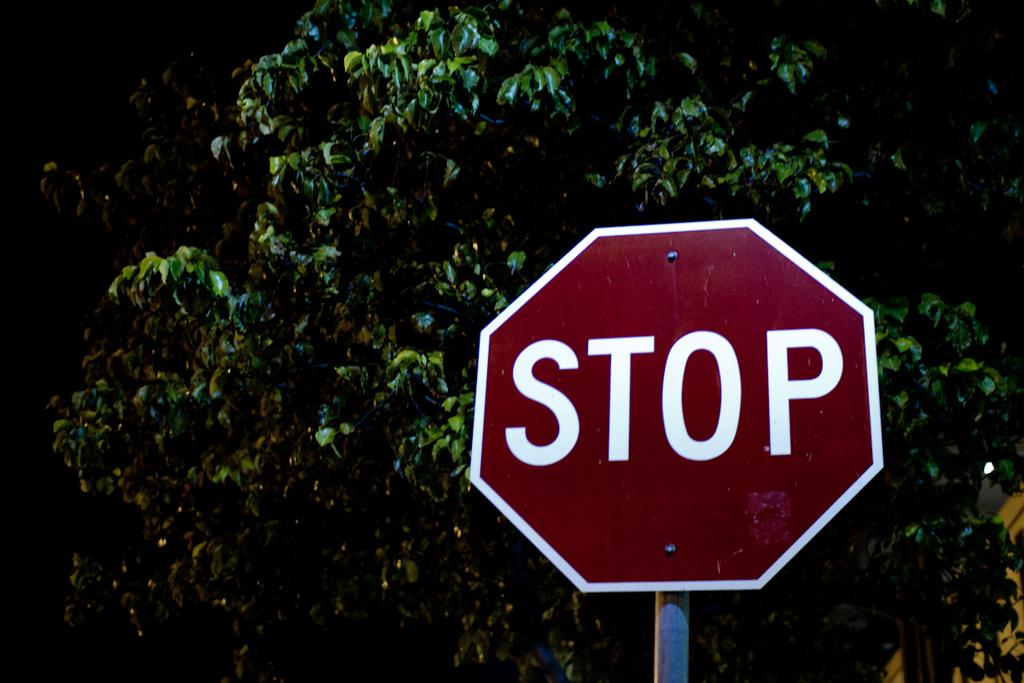Provide a one-sentence caption for the provided image. A red stop sign that is in front of trees. 